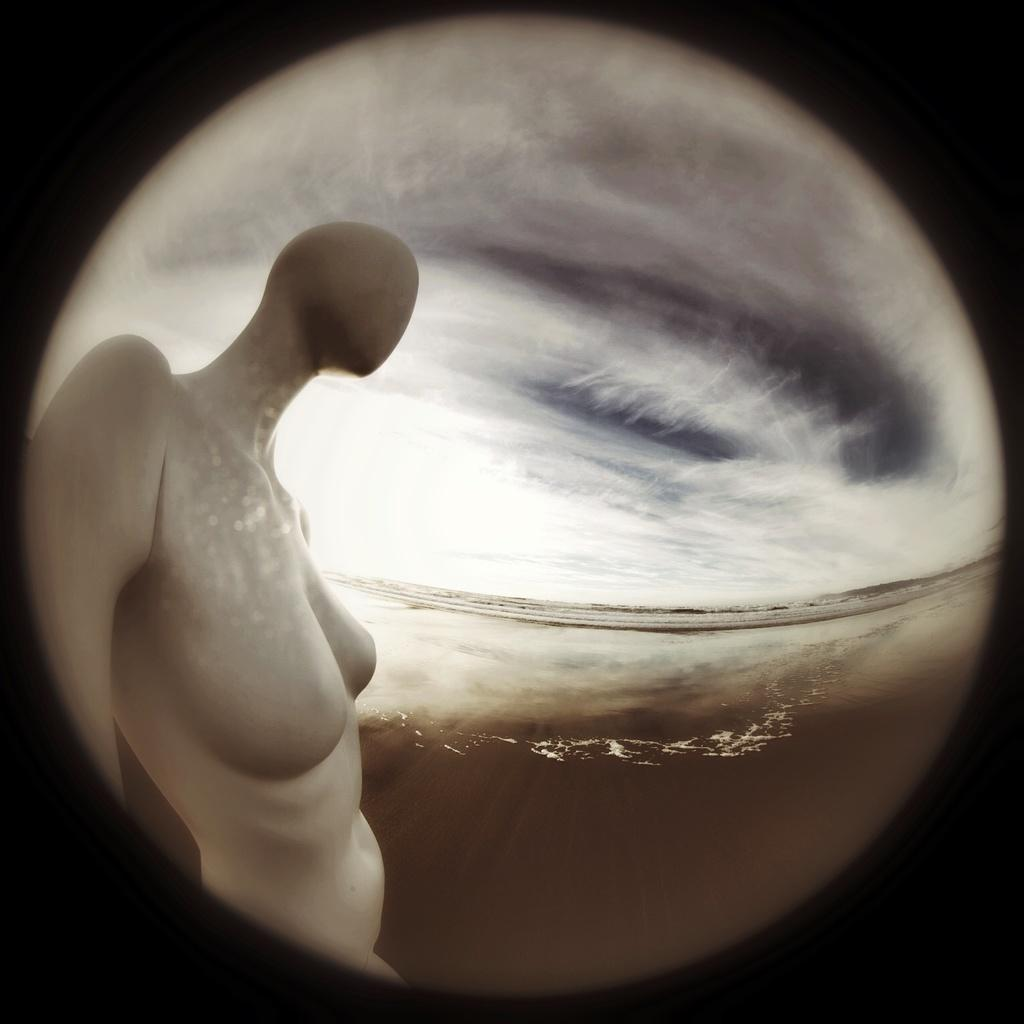What shape is the image? The image is circular. What is depicted in the circular image? There is a person's statue in the image. What can be seen in the background of the image? There are clouds in the sky in the background. What is the color of the border surrounding the circular image? The circular image has a dark color border. How many feet does the stranger have in the image? There is no stranger present in the image, so it is not possible to determine the number of feet they might have. 